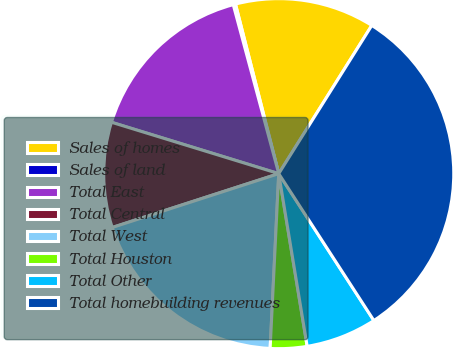Convert chart. <chart><loc_0><loc_0><loc_500><loc_500><pie_chart><fcel>Sales of homes<fcel>Sales of land<fcel>Total East<fcel>Total Central<fcel>Total West<fcel>Total Houston<fcel>Total Other<fcel>Total homebuilding revenues<nl><fcel>12.9%<fcel>0.21%<fcel>16.07%<fcel>9.72%<fcel>19.24%<fcel>3.38%<fcel>6.55%<fcel>31.93%<nl></chart> 